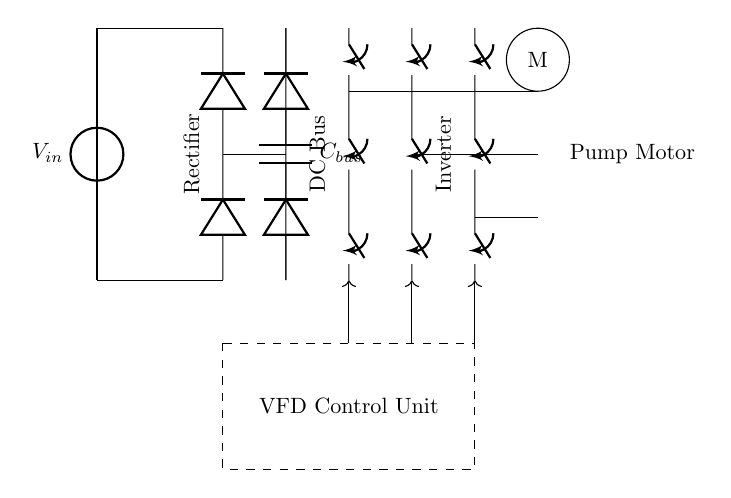What is the input voltage in the circuit? The input voltage is represented by V_in, which is shown as the voltage source at the left side of the diagram.
Answer: V_in What components constitute the rectifier section? The rectifier section includes two diodes arranged to convert AC to DC, as indicated by the two diodes connected from the input voltage source to the DC bus.
Answer: Two diodes What is the function of the capacitor labeled C_bus? The capacitor C_bus acts as a filtering device in the DC bus, stabilizing the DC voltage by smoothing out the ripples from the rectification process.
Answer: Filtering How is the inverter connected to the motor? The inverter is connected to the motor through three lines, correlating to the three closing switches that control the output for variable frequency operation.
Answer: Three lines What is the role of the VFD Control Unit? The VFD Control Unit manages the control signals that dictate the operation of the inverter and motor, allowing for variable speed control based on the demand.
Answer: Variable speed control Which part of the circuit provides AC to the motor? The inverter section provides AC to the motor, as it converts the DC power from the DC bus back into variable frequency AC for motor control.
Answer: Inverter What type of load does this circuit primarily control? This circuit primarily controls a pump motor used in water treatment facilities, indicating that it is designed for fluid movement in industrial applications.
Answer: Pump motor 